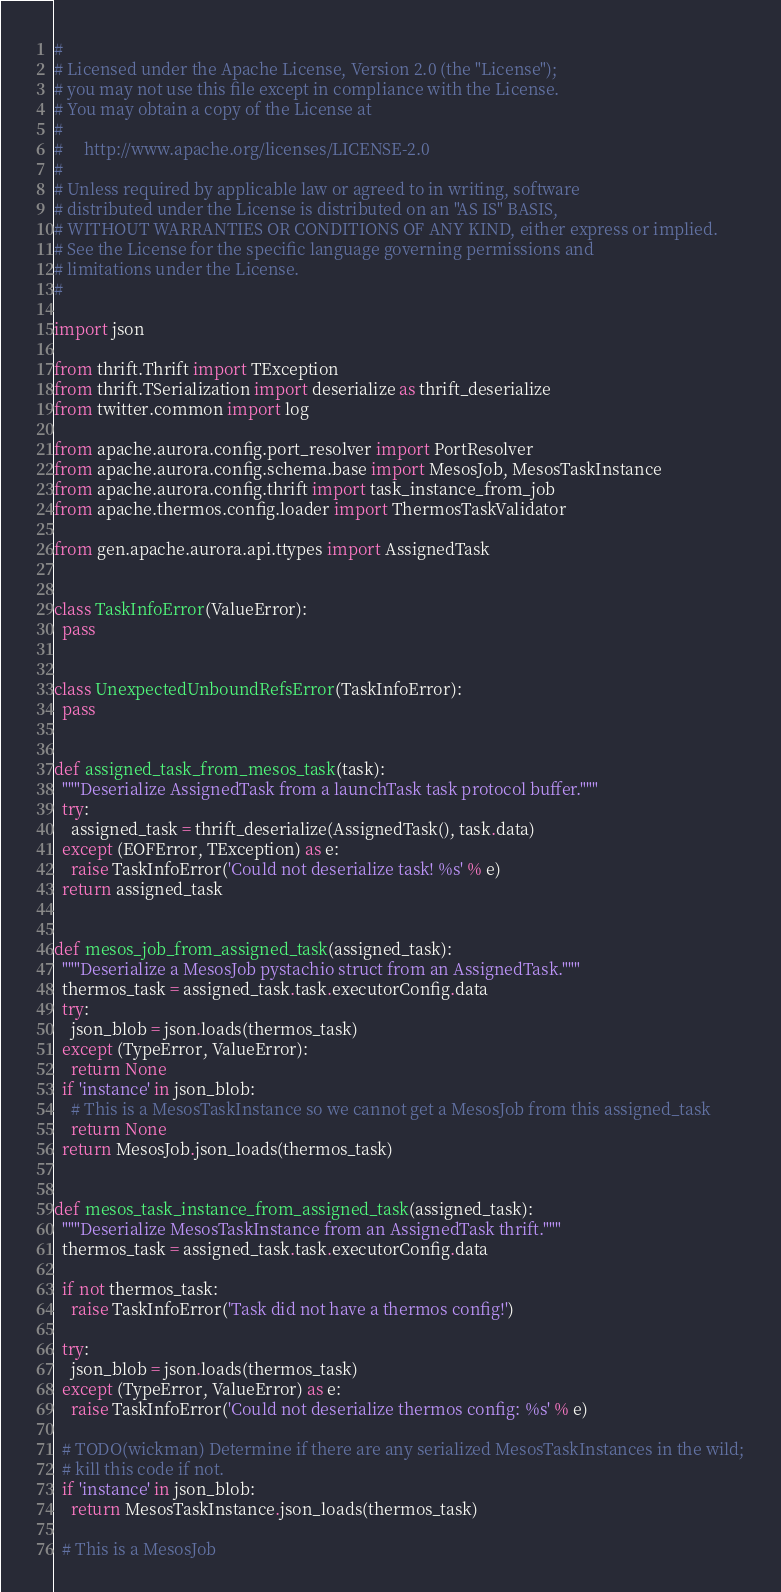<code> <loc_0><loc_0><loc_500><loc_500><_Python_>#
# Licensed under the Apache License, Version 2.0 (the "License");
# you may not use this file except in compliance with the License.
# You may obtain a copy of the License at
#
#     http://www.apache.org/licenses/LICENSE-2.0
#
# Unless required by applicable law or agreed to in writing, software
# distributed under the License is distributed on an "AS IS" BASIS,
# WITHOUT WARRANTIES OR CONDITIONS OF ANY KIND, either express or implied.
# See the License for the specific language governing permissions and
# limitations under the License.
#

import json

from thrift.Thrift import TException
from thrift.TSerialization import deserialize as thrift_deserialize
from twitter.common import log

from apache.aurora.config.port_resolver import PortResolver
from apache.aurora.config.schema.base import MesosJob, MesosTaskInstance
from apache.aurora.config.thrift import task_instance_from_job
from apache.thermos.config.loader import ThermosTaskValidator

from gen.apache.aurora.api.ttypes import AssignedTask


class TaskInfoError(ValueError):
  pass


class UnexpectedUnboundRefsError(TaskInfoError):
  pass


def assigned_task_from_mesos_task(task):
  """Deserialize AssignedTask from a launchTask task protocol buffer."""
  try:
    assigned_task = thrift_deserialize(AssignedTask(), task.data)
  except (EOFError, TException) as e:
    raise TaskInfoError('Could not deserialize task! %s' % e)
  return assigned_task


def mesos_job_from_assigned_task(assigned_task):
  """Deserialize a MesosJob pystachio struct from an AssignedTask."""
  thermos_task = assigned_task.task.executorConfig.data
  try:
    json_blob = json.loads(thermos_task)
  except (TypeError, ValueError):
    return None
  if 'instance' in json_blob:
    # This is a MesosTaskInstance so we cannot get a MesosJob from this assigned_task
    return None
  return MesosJob.json_loads(thermos_task)


def mesos_task_instance_from_assigned_task(assigned_task):
  """Deserialize MesosTaskInstance from an AssignedTask thrift."""
  thermos_task = assigned_task.task.executorConfig.data

  if not thermos_task:
    raise TaskInfoError('Task did not have a thermos config!')

  try:
    json_blob = json.loads(thermos_task)
  except (TypeError, ValueError) as e:
    raise TaskInfoError('Could not deserialize thermos config: %s' % e)

  # TODO(wickman) Determine if there are any serialized MesosTaskInstances in the wild;
  # kill this code if not.
  if 'instance' in json_blob:
    return MesosTaskInstance.json_loads(thermos_task)

  # This is a MesosJob</code> 